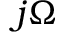Convert formula to latex. <formula><loc_0><loc_0><loc_500><loc_500>j \Omega</formula> 